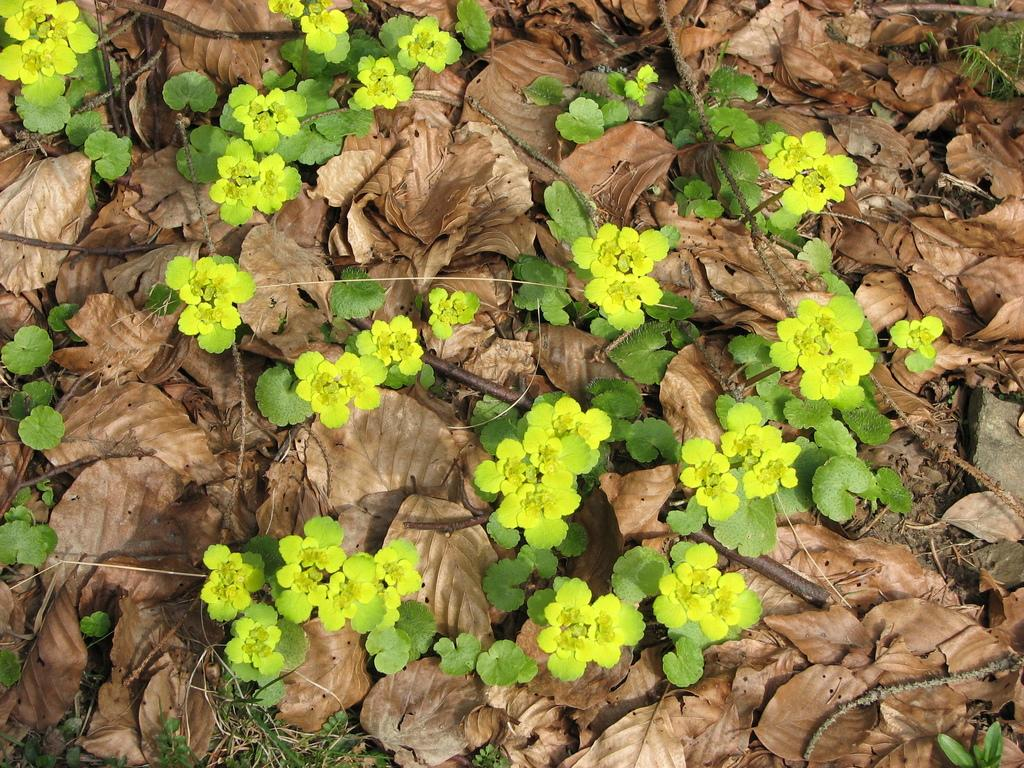What type of vegetation is in the image? There are small plants in the image. Where are the plants located? The plants are on the land. What else can be seen on the land in the image? Dry leaves are present all over the land. How many tickets does the porter have in the image? There is no porter or tickets present in the image. What type of recess is visible in the image? There is no recess present in the image. 